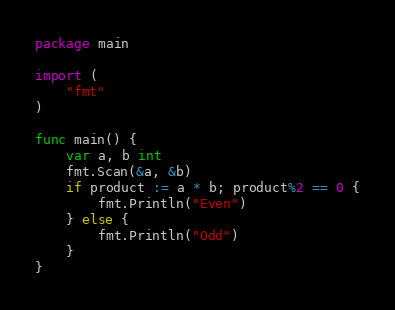<code> <loc_0><loc_0><loc_500><loc_500><_Go_>package main

import (
    "fmt"
)

func main() {
    var a, b int
    fmt.Scan(&a, &b)
    if product := a * b; product%2 == 0 {
        fmt.Println("Even")
    } else {
        fmt.Println("Odd")
    }
}</code> 